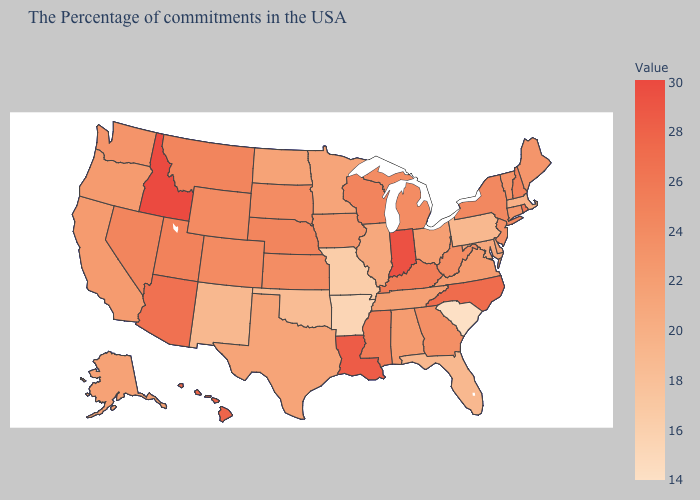Does Idaho have the highest value in the USA?
Short answer required. Yes. Does Louisiana have the highest value in the South?
Answer briefly. Yes. Is the legend a continuous bar?
Give a very brief answer. Yes. Does Idaho have the highest value in the USA?
Short answer required. Yes. 